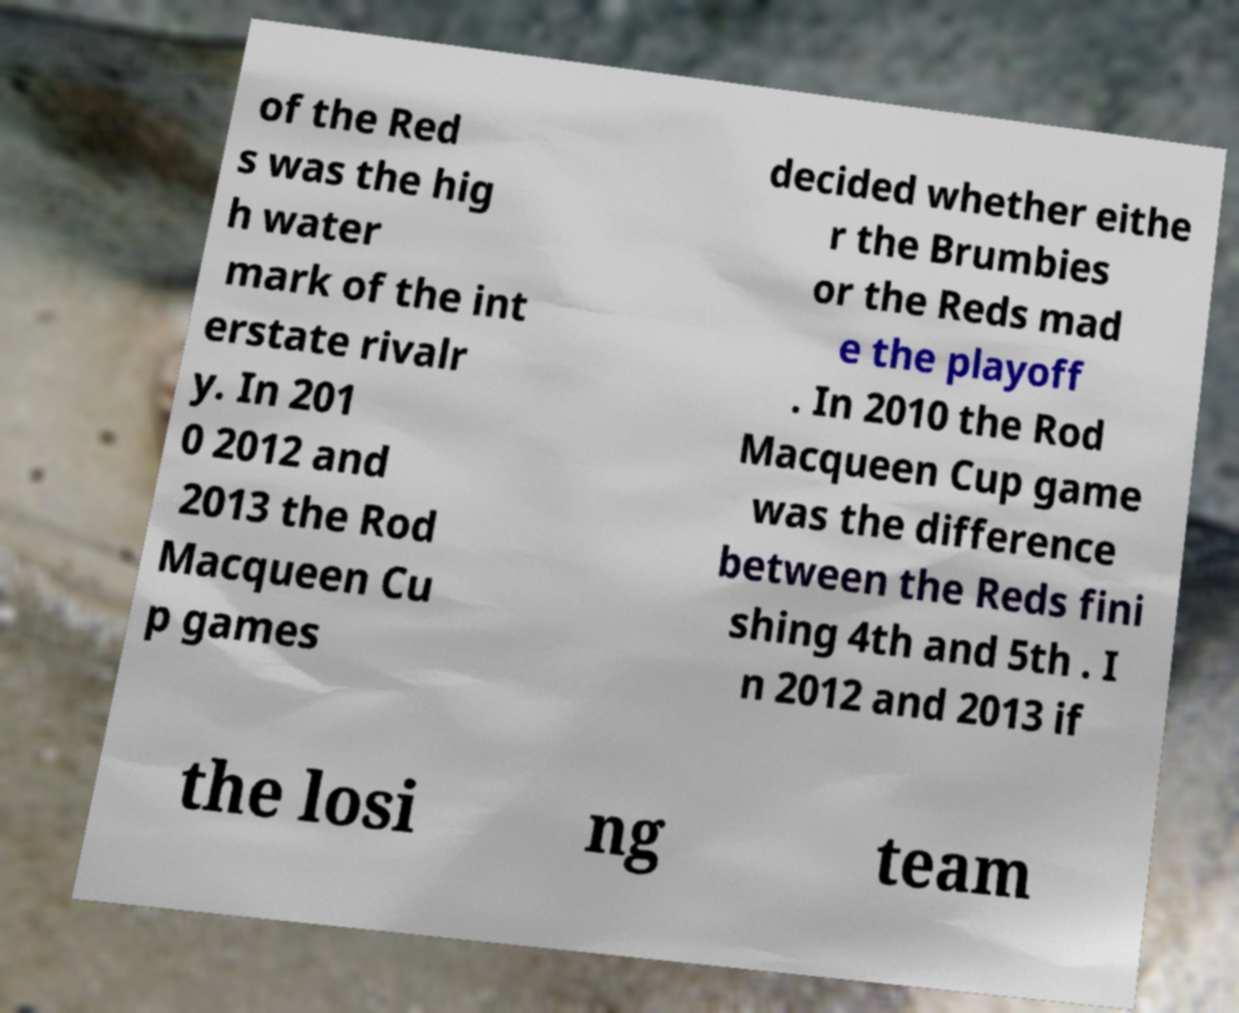I need the written content from this picture converted into text. Can you do that? of the Red s was the hig h water mark of the int erstate rivalr y. In 201 0 2012 and 2013 the Rod Macqueen Cu p games decided whether eithe r the Brumbies or the Reds mad e the playoff . In 2010 the Rod Macqueen Cup game was the difference between the Reds fini shing 4th and 5th . I n 2012 and 2013 if the losi ng team 